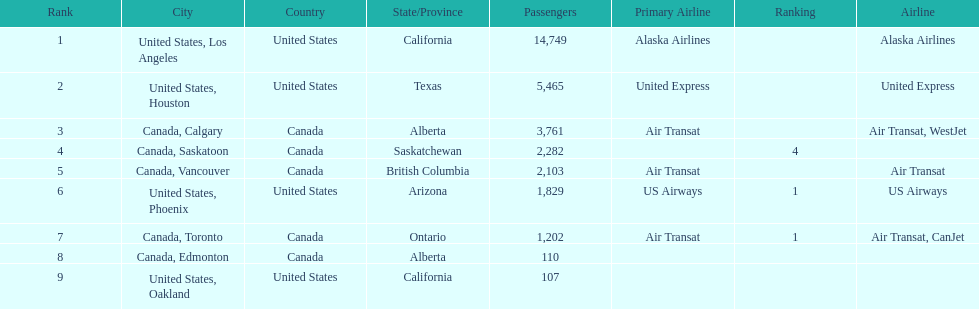What is the average number of passengers in the united states? 5537.5. 